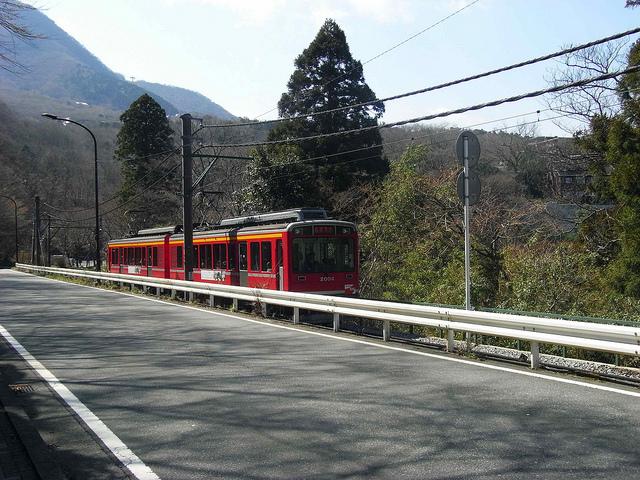Are there cars on the road?
Quick response, please. No. Do the bushes impede the proper functioning of this railway system?
Short answer required. No. Is the train in the bushes?
Quick response, please. No. 